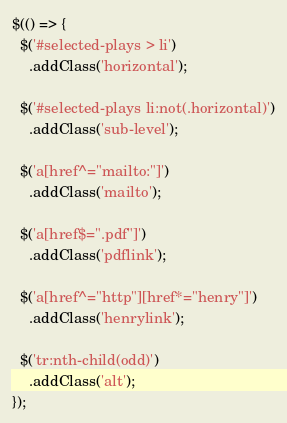<code> <loc_0><loc_0><loc_500><loc_500><_JavaScript_>$(() => {
  $('#selected-plays > li')
    .addClass('horizontal');

  $('#selected-plays li:not(.horizontal)')
    .addClass('sub-level');

  $('a[href^="mailto:"]')
    .addClass('mailto');

  $('a[href$=".pdf"]')
    .addClass('pdflink');

  $('a[href^="http"][href*="henry"]')
    .addClass('henrylink');

  $('tr:nth-child(odd)')
    .addClass('alt');
});
</code> 